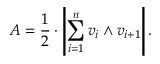Convert formula to latex. <formula><loc_0><loc_0><loc_500><loc_500>A = { \frac { 1 } { 2 } } \cdot \left | \sum _ { i = 1 } ^ { n } v _ { i } \wedge v _ { i + 1 } \right | .</formula> 